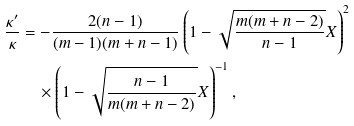<formula> <loc_0><loc_0><loc_500><loc_500>\frac { \kappa ^ { \prime } } { \kappa } & = - \frac { 2 ( n - 1 ) } { ( m - 1 ) ( m + n - 1 ) } \left ( 1 - \sqrt { \frac { m ( m + n - 2 ) } { n - 1 } } X \right ) ^ { 2 } \\ & \quad \times \left ( 1 - \sqrt { \frac { n - 1 } { m ( m + n - 2 ) } } X \right ) ^ { - 1 } ,</formula> 